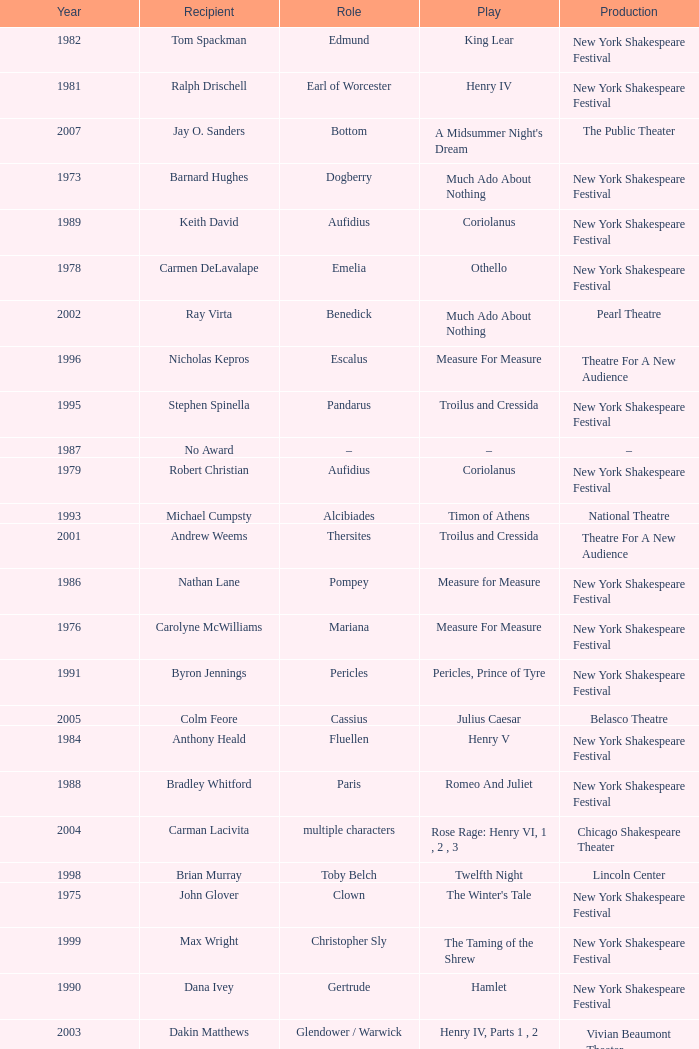Name the play for 1976 Measure For Measure. 